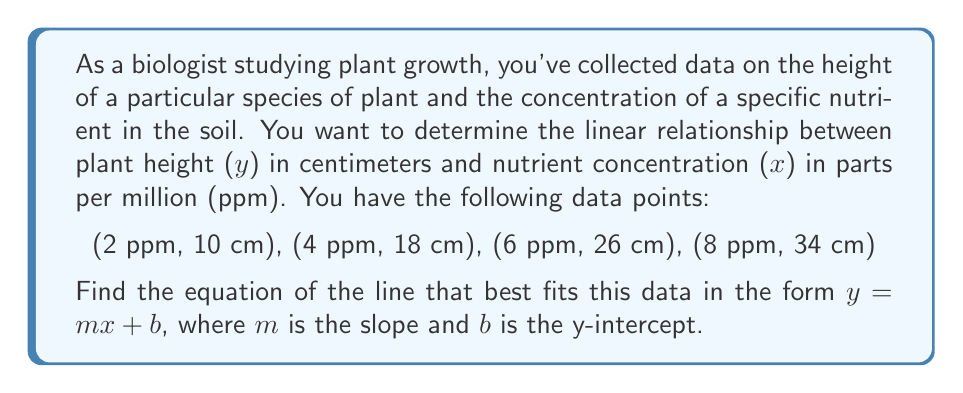Provide a solution to this math problem. To find the equation of the line, we need to calculate the slope (m) and y-intercept (b).

1. Calculate the slope (m):
   We can use any two points to calculate the slope. Let's use (2, 10) and (8, 34).
   
   $$m = \frac{y_2 - y_1}{x_2 - x_1} = \frac{34 - 10}{8 - 2} = \frac{24}{6} = 4$$

   The slope is 4 cm/ppm, indicating that for every 1 ppm increase in nutrient concentration, the plant height increases by 4 cm.

2. Verify the slope using other pairs of points to ensure consistency.

3. Find the y-intercept (b):
   Use the point-slope form of a line: $y - y_1 = m(x - x_1)$
   Let's use the point (2, 10):
   
   $$y - 10 = 4(x - 2)$$
   $$y = 4x - 8 + 10$$
   $$y = 4x + 2$$

   Therefore, the y-intercept (b) is 2.

4. The equation of the line is:
   $$y = 4x + 2$$

5. Verify the equation by plugging in the other data points:
   For (4, 18): $18 = 4(4) + 2 = 18$ (correct)
   For (6, 26): $26 = 4(6) + 2 = 26$ (correct)

This linear equation represents the relationship between plant height (y) in centimeters and nutrient concentration (x) in ppm.
Answer: $y = 4x + 2$, where y is plant height in cm and x is nutrient concentration in ppm. 